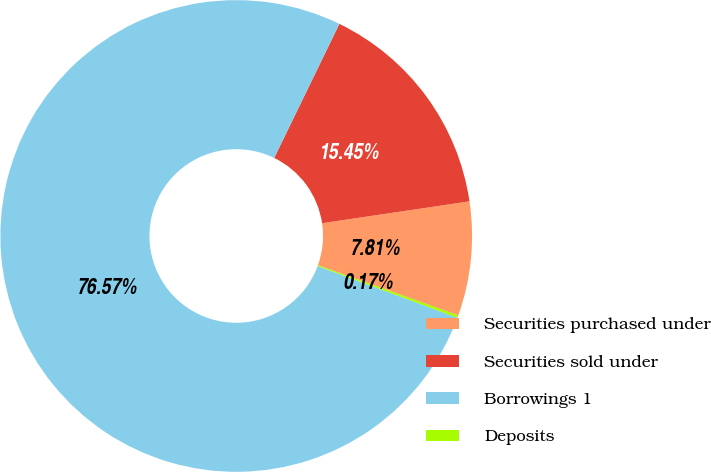<chart> <loc_0><loc_0><loc_500><loc_500><pie_chart><fcel>Securities purchased under<fcel>Securities sold under<fcel>Borrowings 1<fcel>Deposits<nl><fcel>7.81%<fcel>15.45%<fcel>76.56%<fcel>0.17%<nl></chart> 